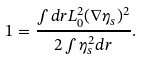<formula> <loc_0><loc_0><loc_500><loc_500>1 = \frac { \int d { r } L _ { 0 } ^ { 2 } ( \nabla \eta _ { s } ) ^ { 2 } } { 2 \int \eta ^ { 2 } _ { s } d { r } } .</formula> 